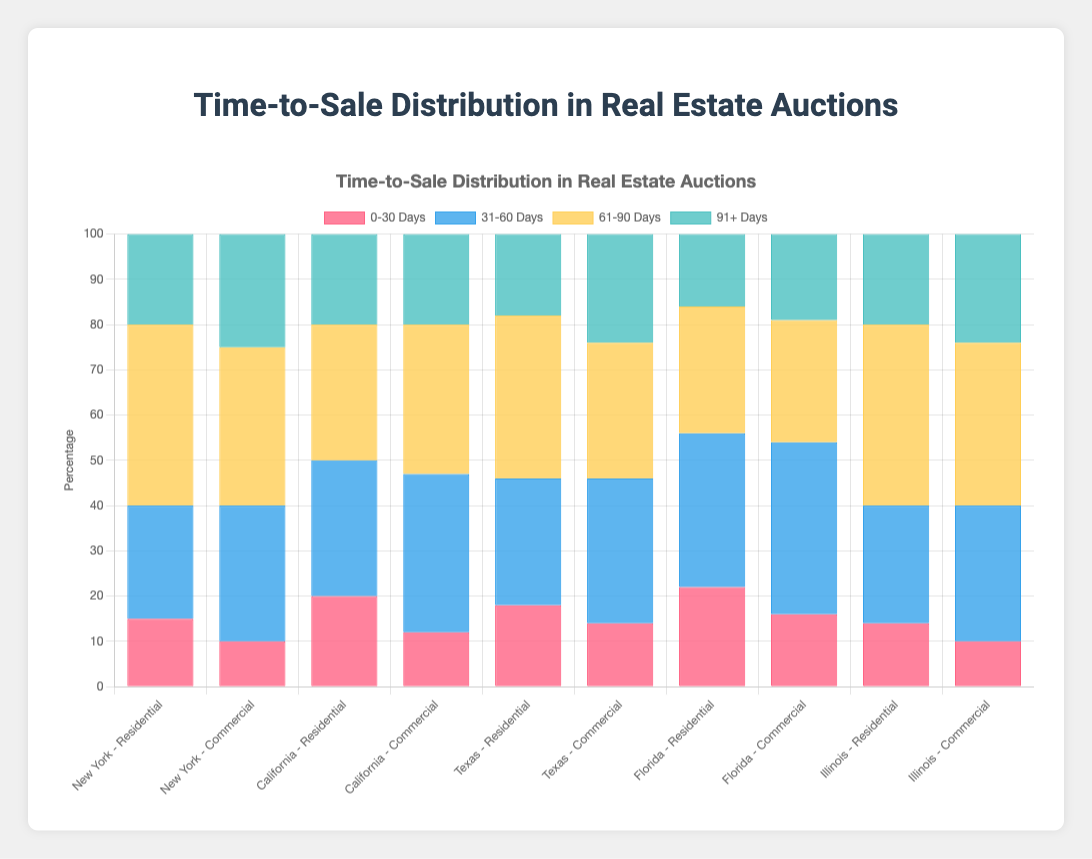Which region has the highest percentage of properties sold in 31-60 days? Check each region for the 31-60 days category and compare the values. Florida has the highest with 34% for Residential and 38% for Commercial.
Answer: Florida In which region and property type combination does the 0-30 days category have the lowest percentage? Look for the lowest value in the 0-30 days category across all regions and property types. New York Commercial has the lowest with 10%.
Answer: New York Commercial What is the combined percentage of properties sold within 60 days in Texas Residential? Add the percentages of the 0-30 days and 31-60 days categories in Texas Residential: 18% + 28%.
Answer: 46% Compare the percentages of properties sold in 61-90 days for New York Residential and Commercial. Which is higher? Compare the 61-90 days value of New York Residential (40%) with New York Commercial (35%). New York Residential has a higher percentage.
Answer: New York Residential Which region has the smallest difference in percentage between the 31-60 days and 61-90 days categories for Residential properties? Calculate the differences for each region's Residential properties and find the smallest: New York (15%), California (0%), Texas (8%), Florida (6%), Illinois (-14%). California has the smallest difference (0%).
Answer: California What is the total percentage of Commercial properties sold within 91+ days across all regions? Sum the 91+ days percentages for all Commercial properties: 25% (NY) + 20% (CA) + 24% (TX) + 19% (FL) + 24% (IL).
Answer: 112% Which region's Residential properties have the highest percentage sold within 91+ days? Compare the 91+ days percentages for Residential properties across all regions: New York (20%), California (20%), Texas (18%), Florida (16%), Illinois (20%). Several regions have the same highest percentage (20%).
Answer: New York, California, Illinois In which region is there the most significant difference between the Residential and Commercial percentage sold within 0-30 days? Calculate the differences for the 0-30 days category between Residential and Commercial properties in each region: New York (5%), California (8%), Texas (4%), Florida (6%), Illinois (4%). California has the most significant difference (8%).
Answer: California 